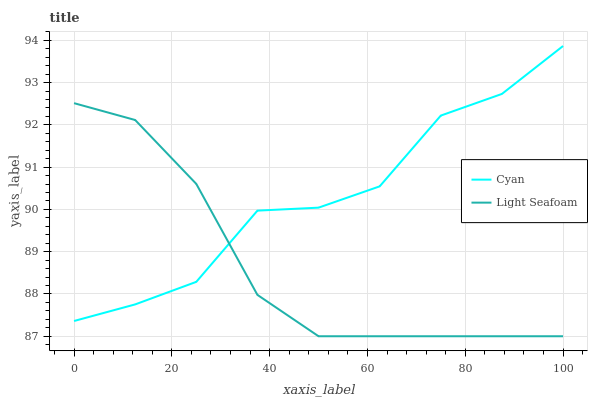Does Light Seafoam have the minimum area under the curve?
Answer yes or no. Yes. Does Cyan have the maximum area under the curve?
Answer yes or no. Yes. Does Light Seafoam have the maximum area under the curve?
Answer yes or no. No. Is Light Seafoam the smoothest?
Answer yes or no. Yes. Is Cyan the roughest?
Answer yes or no. Yes. Is Light Seafoam the roughest?
Answer yes or no. No. Does Cyan have the highest value?
Answer yes or no. Yes. Does Light Seafoam have the highest value?
Answer yes or no. No. Does Light Seafoam intersect Cyan?
Answer yes or no. Yes. Is Light Seafoam less than Cyan?
Answer yes or no. No. Is Light Seafoam greater than Cyan?
Answer yes or no. No. 